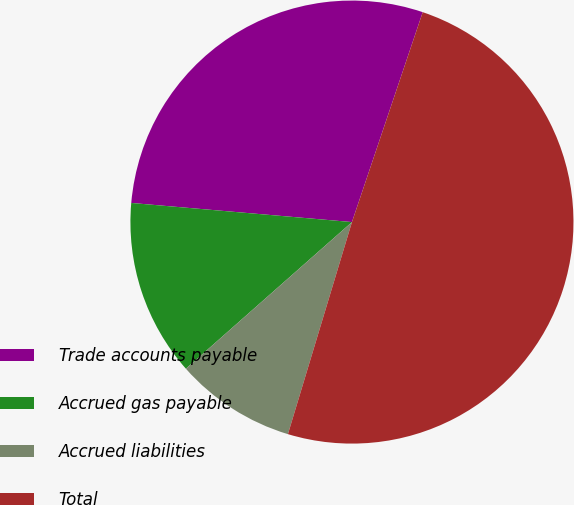<chart> <loc_0><loc_0><loc_500><loc_500><pie_chart><fcel>Trade accounts payable<fcel>Accrued gas payable<fcel>Accrued liabilities<fcel>Total<nl><fcel>28.8%<fcel>12.89%<fcel>8.82%<fcel>49.49%<nl></chart> 